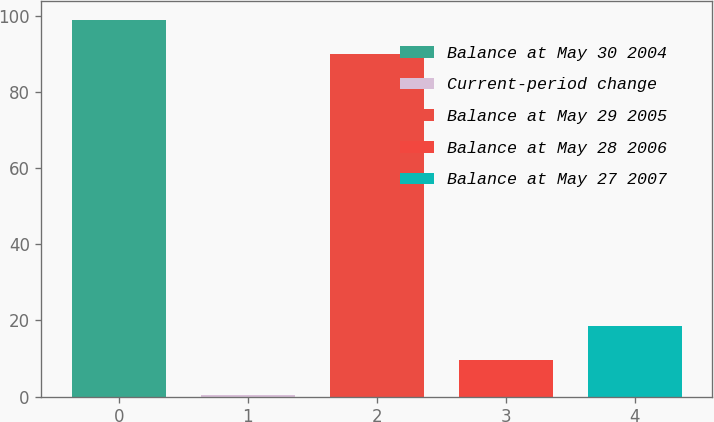Convert chart to OTSL. <chart><loc_0><loc_0><loc_500><loc_500><bar_chart><fcel>Balance at May 30 2004<fcel>Current-period change<fcel>Balance at May 29 2005<fcel>Balance at May 28 2006<fcel>Balance at May 27 2007<nl><fcel>99<fcel>0.5<fcel>90<fcel>9.5<fcel>18.5<nl></chart> 